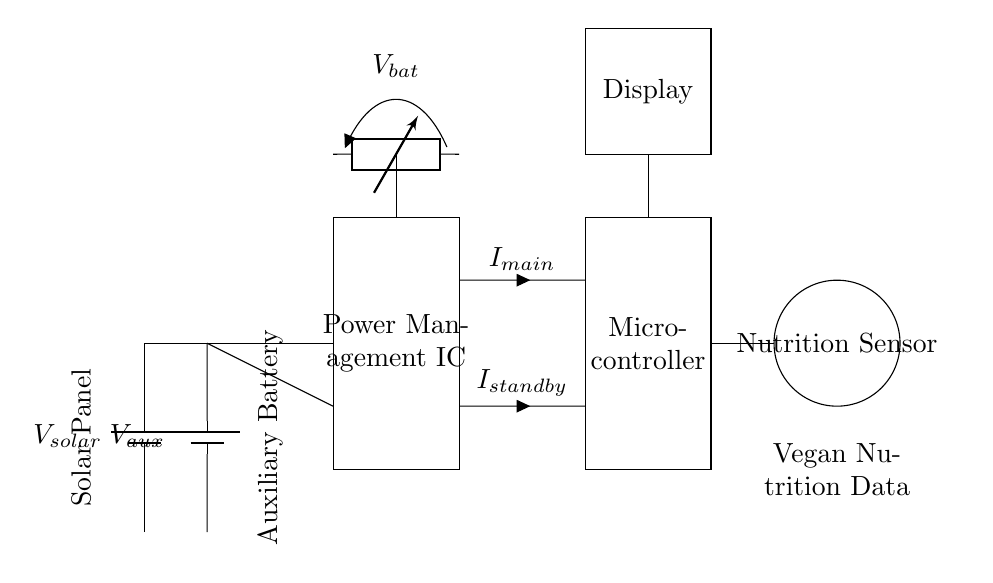What are the two power sources in this circuit? The two power sources are a solar panel and an auxiliary battery. The circuit diagram visibly shows two battery symbols labeled as V_solar and V_aux, indicating these power sources.
Answer: solar panel, auxiliary battery What does the rectangle labeled "Power Management IC" represent? The rectangle labeled "Power Management IC" signifies the integrated circuit responsible for managing the power flow from the two sources to the rest of the components in the circuit. The label clearly identifies this functional component.
Answer: Power Management IC How many connections are made from the Power Management IC to the Microcontroller? There are two connections from the Power Management IC to the Microcontroller, indicated by separate lines leading from the PMIC to the MCU labeled with current symbols I_main and I_standby.
Answer: two connections What is the primary function of the Nutrition Sensor in this circuit? The Nutrition Sensor collects and processes data related to vegan nutrition, as implied by its label and the context of the circuit. It interacts with the Microcontroller, which likely processes this data for display or further analysis.
Answer: collect vegan nutrition data What are the output components connected to the Microcontroller? The output components connected to the Microcontroller are the Display and the Nutrition Sensor. The connections are visually represented by lines leading from the microcontroller to these components, indicating they receive data from the MCU.
Answer: Display, Nutrition Sensor What current flows from the Power Management IC to the Microcontroller during standby? The current that flows from the Power Management IC to the Microcontroller during standby is denoted as I_standby, represented on the circuit by a labeled line that connects these two components.
Answer: I_standby What is the purpose of the battery level indicator in this circuit? The battery level indicator serves to monitor the voltage of the battery, ensuring the system operates efficiently by providing feedback on the battery's charge state. It is visually depicted in the circuit with a voltage symbol.
Answer: monitor battery voltage 